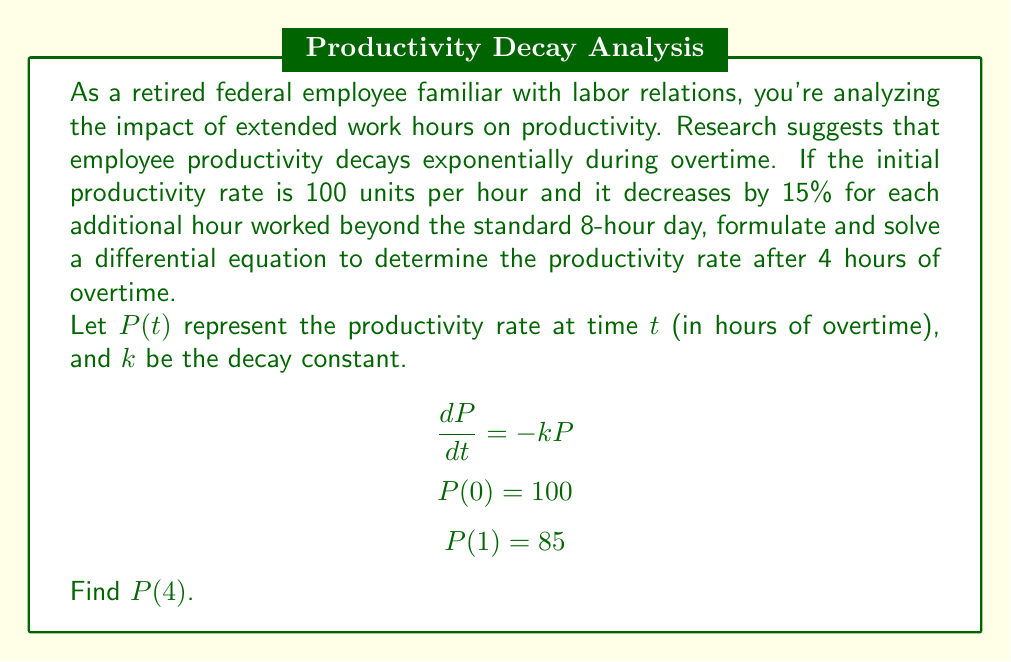Provide a solution to this math problem. To solve this problem, we'll follow these steps:

1) First, we need to find the decay constant $k$. We know that after 1 hour of overtime, the productivity decreases by 15%, so:

   $P(1) = 100 \cdot (1 - 0.15) = 85$

2) The general solution to the differential equation $\frac{dP}{dt} = -kP$ is:

   $P(t) = Ce^{-kt}$

   Where $C$ is a constant we can determine from the initial condition.

3) Using the initial condition $P(0) = 100$:

   $100 = Ce^{-k(0)} = C$

4) Now we can use $P(1) = 85$ to find $k$:

   $85 = 100e^{-k(1)}$
   $0.85 = e^{-k}$
   $\ln(0.85) = -k$
   $k = -\ln(0.85) \approx 0.1625$

5) Now that we have $k$, we can find $P(4)$:

   $P(4) = 100e^{-0.1625(4)}$

6) Calculating this:

   $P(4) = 100e^{-0.65} \approx 52.2$

Therefore, after 4 hours of overtime, the productivity rate will be approximately 52.2 units per hour.
Answer: $P(4) \approx 52.2$ units per hour 